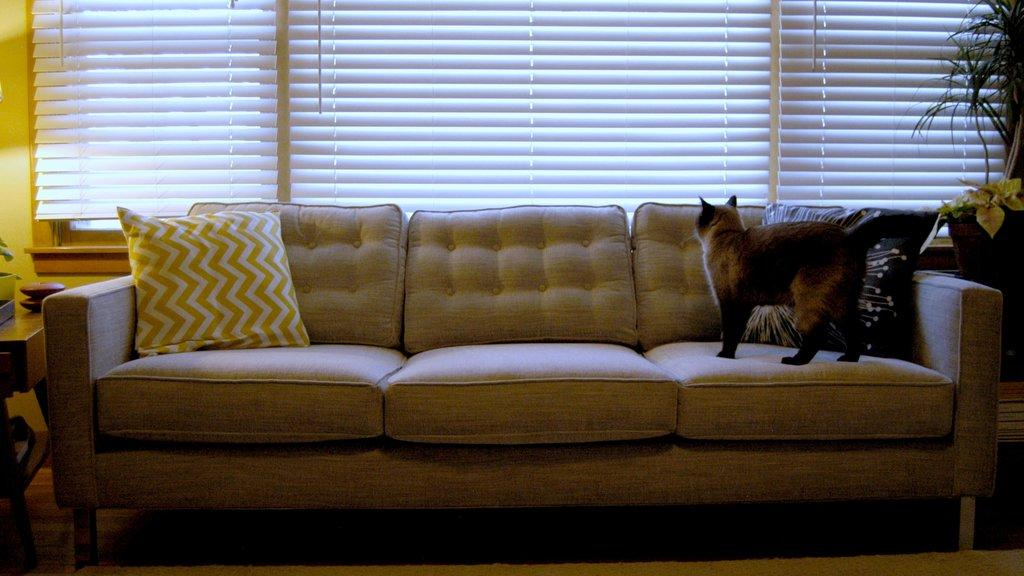What piece of furniture is located on the left side of the image? There is a table on the left side of the image. What is in the middle of the image? There is a sofa in the middle of the image. What is on the sofa? There is a cat on the sofa. What is also on the sofa? There is a pillow on the sofa. What can be seen on the right side of the image? There is a plant on the right side of the image. What type of coal is being used to cook the turkey in the image? There is no coal or turkey present in the image. How does the cat on the sofa get the attention of the plant on the right side of the image? The cat on the sofa is not interacting with the plant in the image, so it cannot get the plant's attention. 